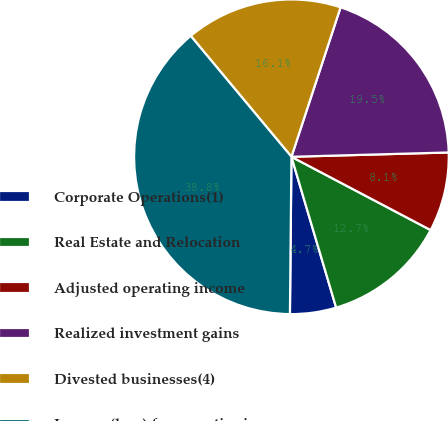Convert chart to OTSL. <chart><loc_0><loc_0><loc_500><loc_500><pie_chart><fcel>Corporate Operations(1)<fcel>Real Estate and Relocation<fcel>Adjusted operating income<fcel>Realized investment gains<fcel>Divested businesses(4)<fcel>Income (loss) from continuing<nl><fcel>4.74%<fcel>12.7%<fcel>8.15%<fcel>19.51%<fcel>16.11%<fcel>38.79%<nl></chart> 